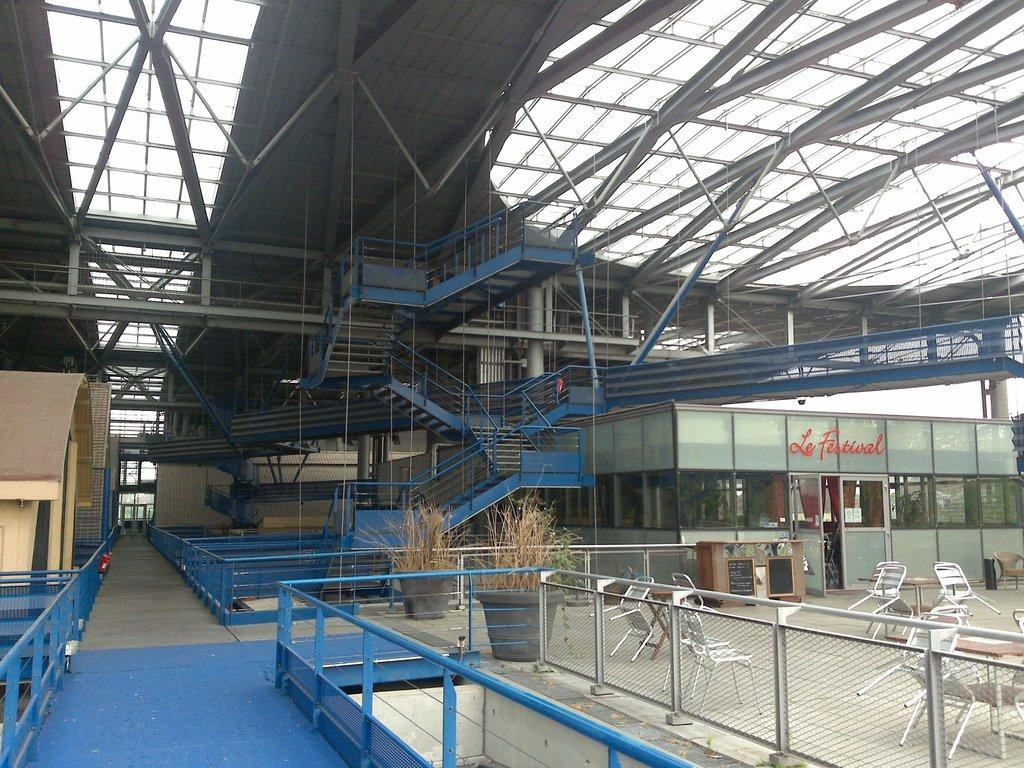What type of structure is present in the image? There are stairs in the image. What other type of structure can be seen in the image? There is a shed in the image. What type of furniture is visible in the image? There are chairs in the image. What type of living organisms are present in the image? There are plants in the image. What type of bait is used to catch fish in the image? There is no mention of fishing or bait in the image; it features stairs, a shed, chairs, and plants. What type of substance is being measured in the image? There is no indication of any substance being measured in the image. 